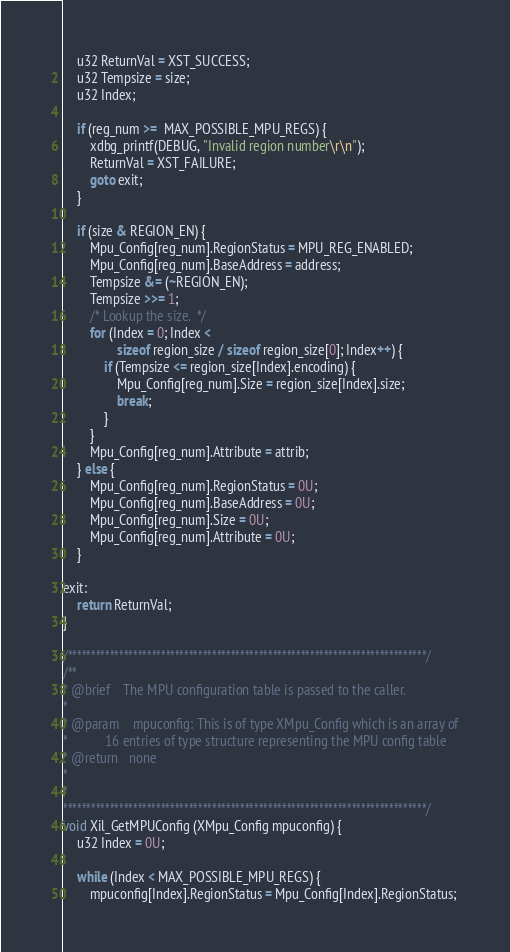<code> <loc_0><loc_0><loc_500><loc_500><_C_>	u32 ReturnVal = XST_SUCCESS;
	u32 Tempsize = size;
	u32 Index;

	if (reg_num >=  MAX_POSSIBLE_MPU_REGS) {
		xdbg_printf(DEBUG, "Invalid region number\r\n");
		ReturnVal = XST_FAILURE;
		goto exit;
	}

	if (size & REGION_EN) {
		Mpu_Config[reg_num].RegionStatus = MPU_REG_ENABLED;
		Mpu_Config[reg_num].BaseAddress = address;
		Tempsize &= (~REGION_EN);
		Tempsize >>= 1;
		/* Lookup the size.  */
		for (Index = 0; Index <
				sizeof region_size / sizeof region_size[0]; Index++) {
			if (Tempsize <= region_size[Index].encoding) {
				Mpu_Config[reg_num].Size = region_size[Index].size;
				break;
			}
		}
		Mpu_Config[reg_num].Attribute = attrib;
	} else {
		Mpu_Config[reg_num].RegionStatus = 0U;
		Mpu_Config[reg_num].BaseAddress = 0U;
		Mpu_Config[reg_num].Size = 0U;
		Mpu_Config[reg_num].Attribute = 0U;
	}

exit:
	return ReturnVal;
}

/*****************************************************************************/
/**
* @brief    The MPU configuration table is passed to the caller.
*
* @param	mpuconfig: This is of type XMpu_Config which is an array of
* 			16 entries of type structure representing the MPU config table
* @return	none
*
*
******************************************************************************/
void Xil_GetMPUConfig (XMpu_Config mpuconfig) {
	u32 Index = 0U;

	while (Index < MAX_POSSIBLE_MPU_REGS) {
		mpuconfig[Index].RegionStatus = Mpu_Config[Index].RegionStatus;</code> 